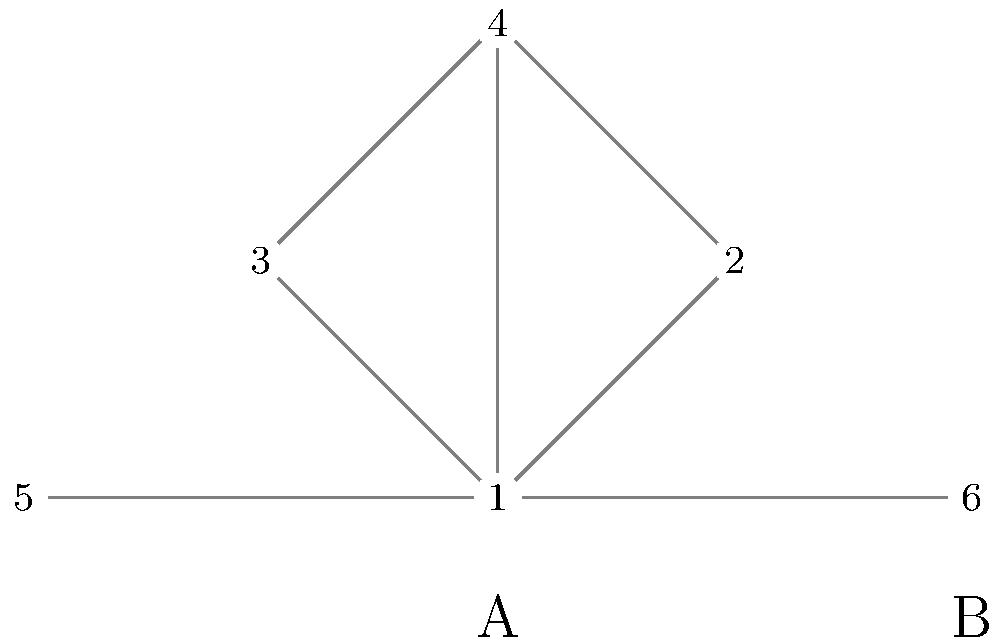Consider the two social network structures represented by the node diagrams above, labeled A and B. Network A consists of nodes 1-4, while network B consists of nodes 1, 5, and 6. Which network structure is more likely to facilitate the rapid spread of misinformation, and what ethical considerations arise from this difference in network topology? To answer this question, we need to analyze the structural differences between networks A and B and their implications for information spread and ethical considerations:

1. Network A (nodes 1-4):
   - This is a more densely connected network with a central node (1) connected to all other nodes.
   - It resembles a "star" or "hub-and-spoke" structure.
   - Information can quickly spread from the central node to all others in one step.

2. Network B (nodes 1, 5, 6):
   - This is a less densely connected network with no central hub.
   - It resembles a "chain" or "line" structure.
   - Information takes more steps to spread from one end to the other.

3. Rapid spread of misinformation:
   - Network A is more likely to facilitate rapid spread due to its centralized structure.
   - The central node (1) can quickly disseminate information to all other nodes.
   - In Network B, information spread is slower and more controlled.

4. Ethical considerations:
   a) Information control:
      - Network A: The central node has disproportionate influence, raising concerns about power dynamics and manipulation.
      - Network B: More balanced distribution of information control.

   b) Responsibility:
      - Network A: Greater ethical burden on the central node to verify information before sharing.
      - Network B: Shared responsibility among all nodes for information verification.

   c) Resilience to misinformation:
      - Network A: More vulnerable to widespread misinformation if the central node is compromised.
      - Network B: More resilient, as misinformation spreads more slowly.

   d) Privacy and surveillance:
      - Network A: Central node may have access to more information, raising privacy concerns.
      - Network B: More distributed information flow, potentially offering better privacy.

   e) Social equality:
      - Network A: Potential for inequality in information access and influence.
      - Network B: More egalitarian structure with equal roles for all nodes.

5. Ethical implications:
   - The choice of network structure impacts the balance between rapid information spread and the risk of misinformation proliferation.
   - It affects individual privacy, social equality, and the distribution of ethical responsibility.
   - Network designers and participants must consider these ethical dimensions when creating or participating in social networks.
Answer: Network A is more likely to spread misinformation rapidly. Ethical considerations include: information control, responsibility distribution, network resilience, privacy concerns, and social equality. 